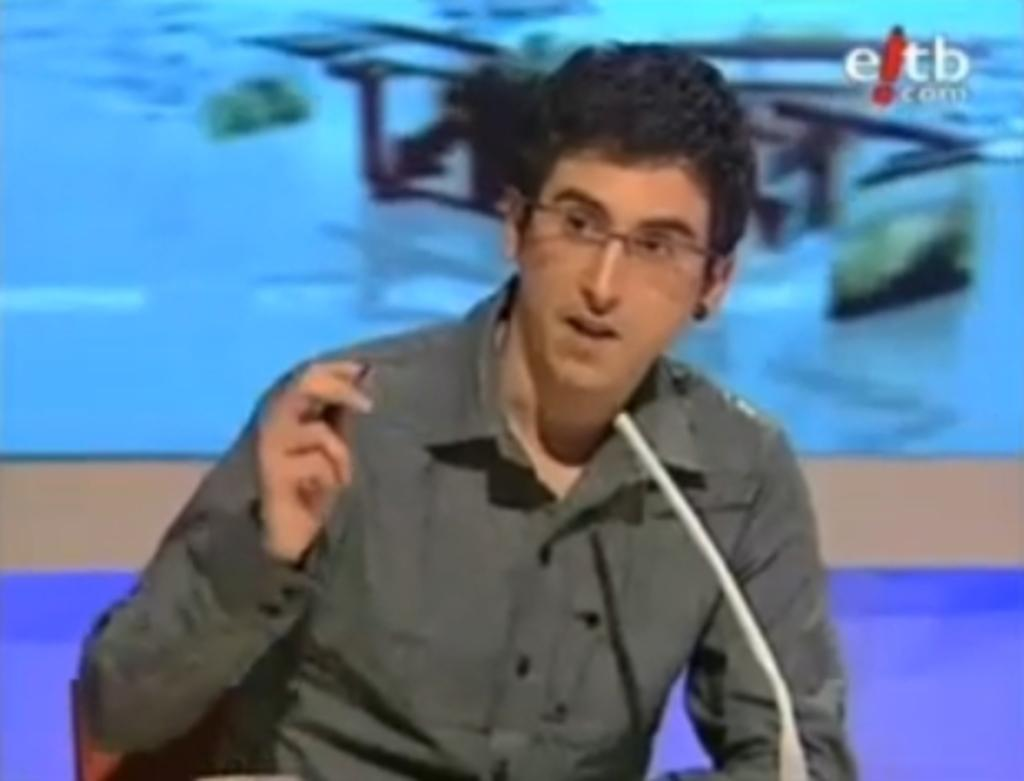Who is the main subject in the image? There is a man in the center of the image. What object is in front of the man? There is a microphone in front of the man. What can be seen in the background of the image? There is a poster in the background of the image. How many kittens are sitting on the microphone in the image? There are no kittens present in the image; it features a man with a microphone and a poster in the background. 